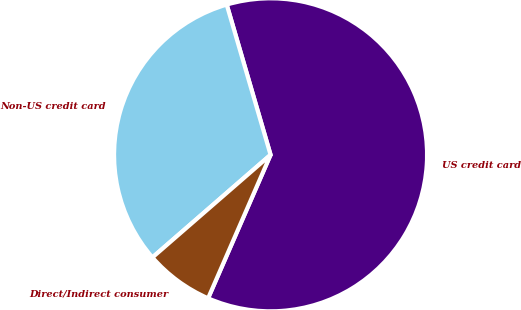<chart> <loc_0><loc_0><loc_500><loc_500><pie_chart><fcel>US credit card<fcel>Non-US credit card<fcel>Direct/Indirect consumer<nl><fcel>61.06%<fcel>31.86%<fcel>7.08%<nl></chart> 